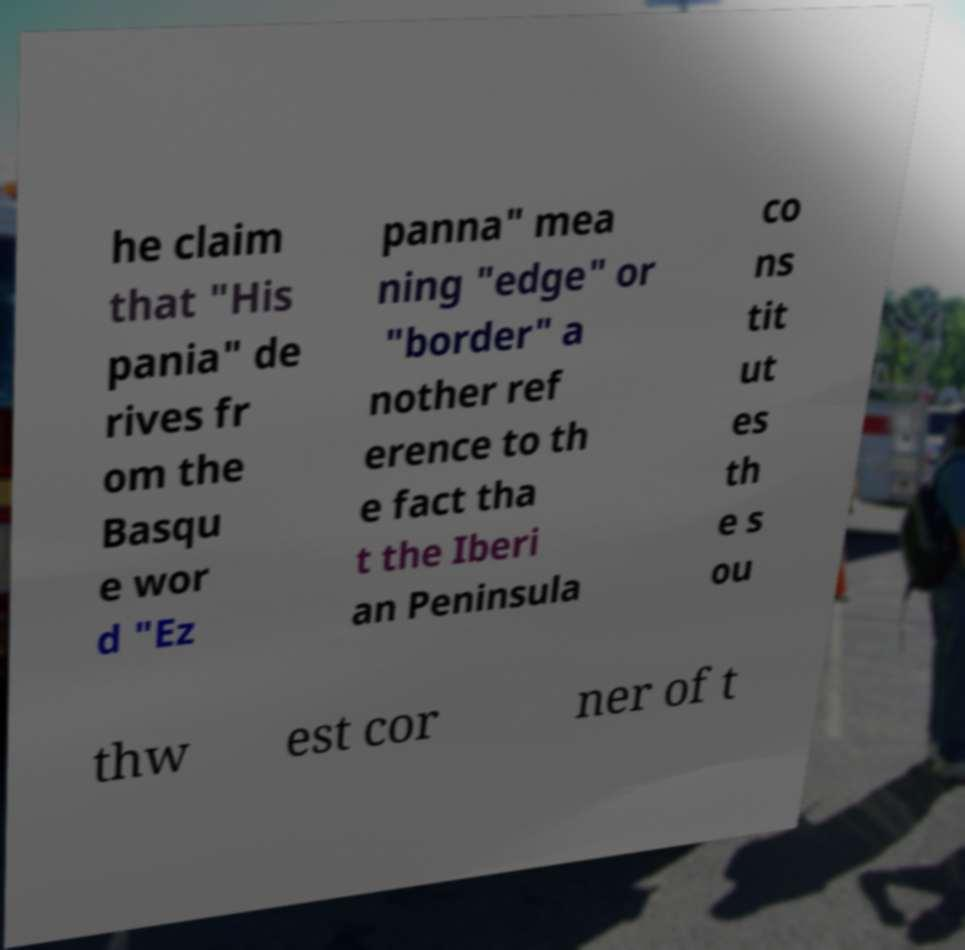Could you extract and type out the text from this image? he claim that "His pania" de rives fr om the Basqu e wor d "Ez panna" mea ning "edge" or "border" a nother ref erence to th e fact tha t the Iberi an Peninsula co ns tit ut es th e s ou thw est cor ner of t 